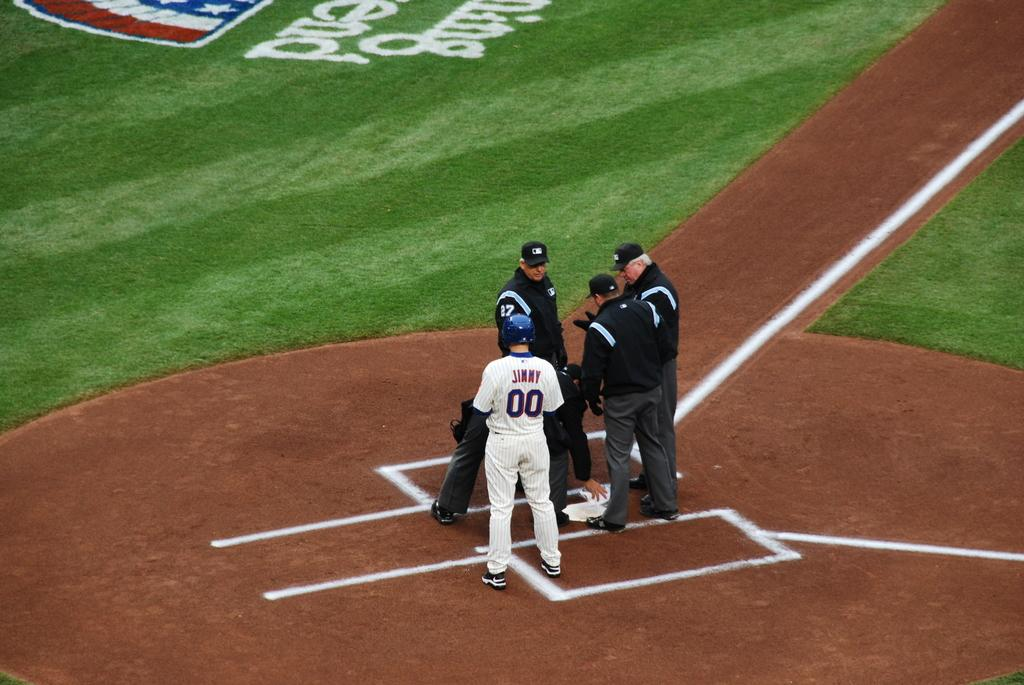How many people are in the image? There is a group of people in the image, but the exact number is not specified. What is the position of the people in the image? The people are standing on the ground in the image. What type of vegetation is visible in front of the people? There is grass in front of the people in the image. What type of bait is being used by the people in the image? There is no indication of any fishing or bait-related activity in the image. 